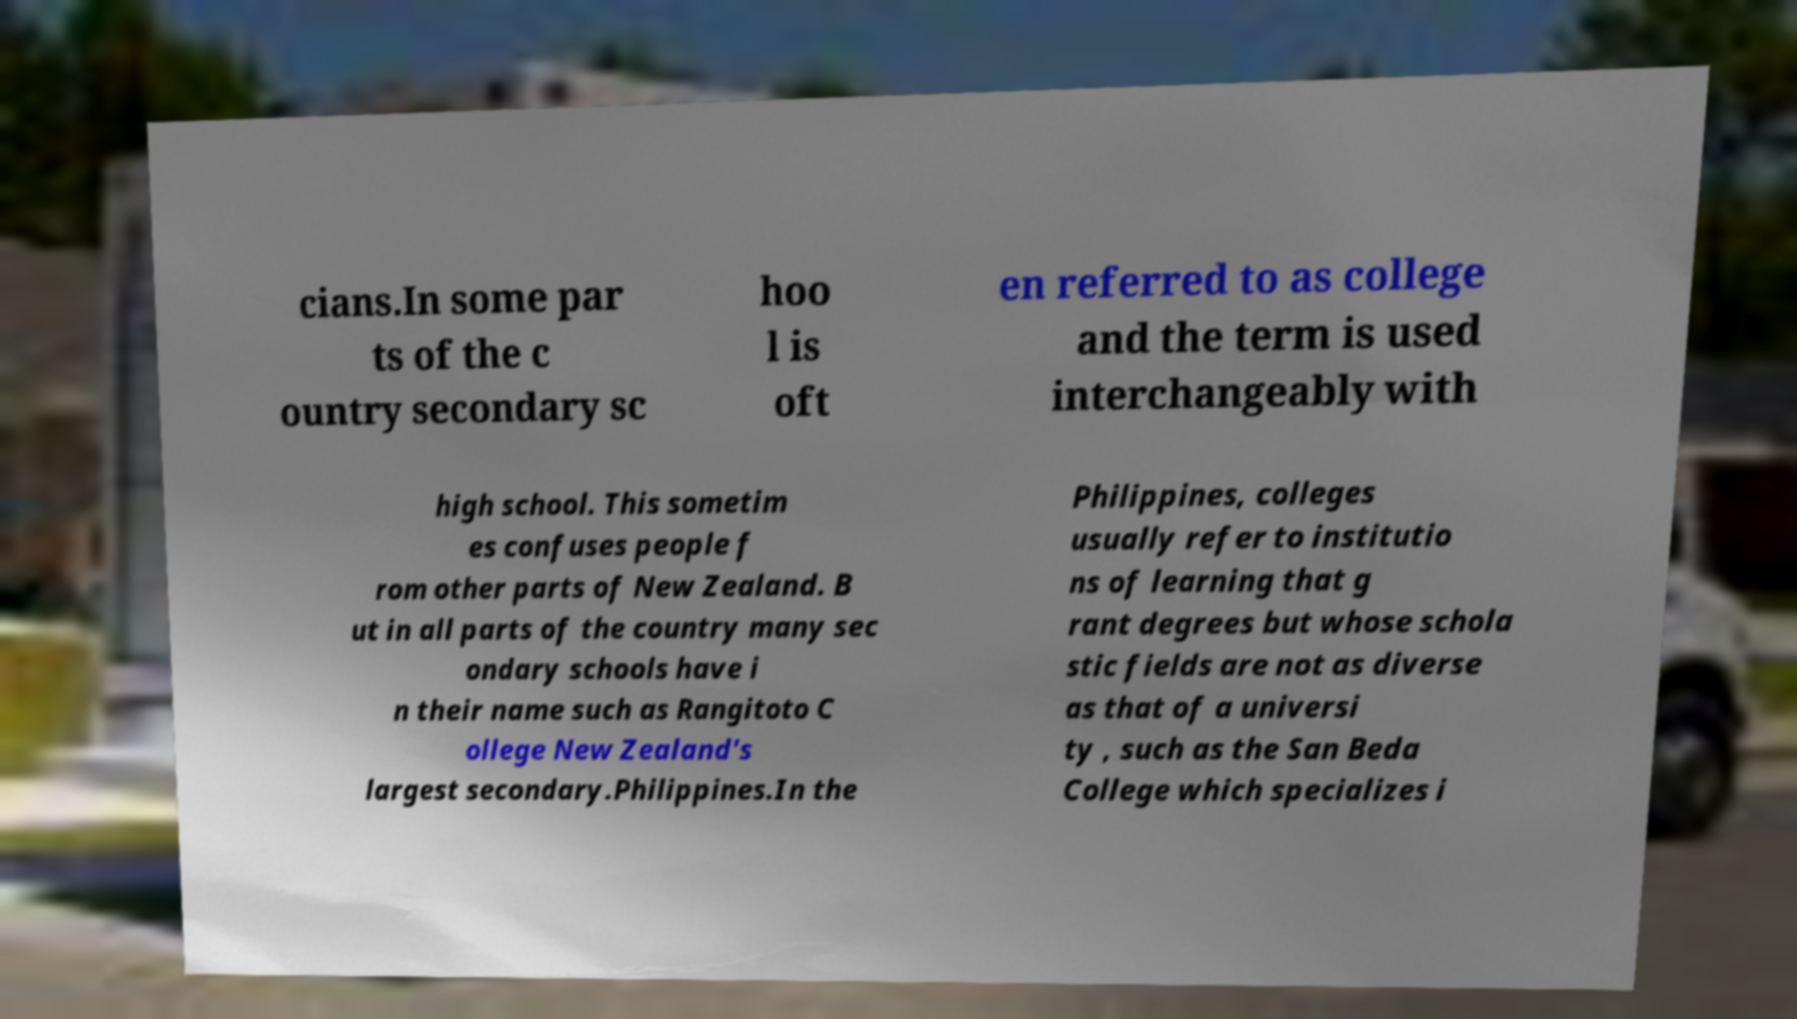Can you read and provide the text displayed in the image?This photo seems to have some interesting text. Can you extract and type it out for me? cians.In some par ts of the c ountry secondary sc hoo l is oft en referred to as college and the term is used interchangeably with high school. This sometim es confuses people f rom other parts of New Zealand. B ut in all parts of the country many sec ondary schools have i n their name such as Rangitoto C ollege New Zealand's largest secondary.Philippines.In the Philippines, colleges usually refer to institutio ns of learning that g rant degrees but whose schola stic fields are not as diverse as that of a universi ty , such as the San Beda College which specializes i 